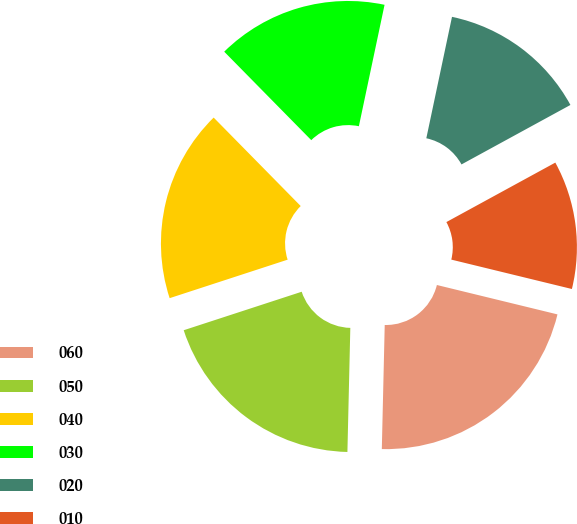Convert chart. <chart><loc_0><loc_0><loc_500><loc_500><pie_chart><fcel>060<fcel>050<fcel>040<fcel>030<fcel>020<fcel>010<nl><fcel>21.57%<fcel>19.61%<fcel>17.65%<fcel>15.69%<fcel>13.73%<fcel>11.76%<nl></chart> 